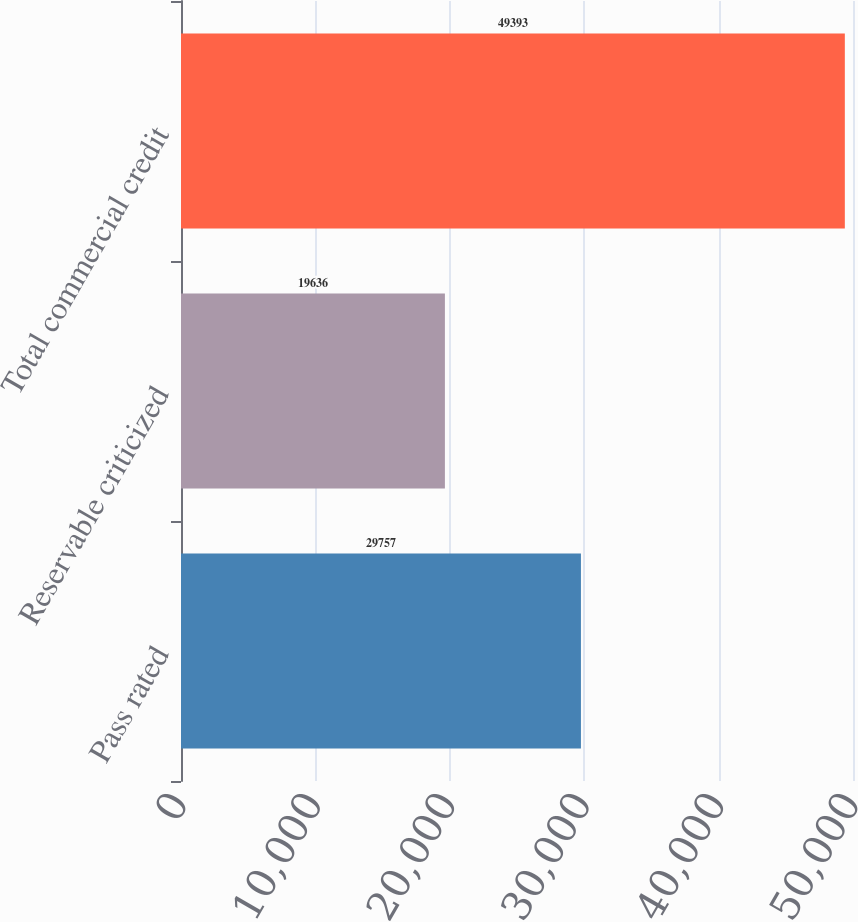Convert chart to OTSL. <chart><loc_0><loc_0><loc_500><loc_500><bar_chart><fcel>Pass rated<fcel>Reservable criticized<fcel>Total commercial credit<nl><fcel>29757<fcel>19636<fcel>49393<nl></chart> 